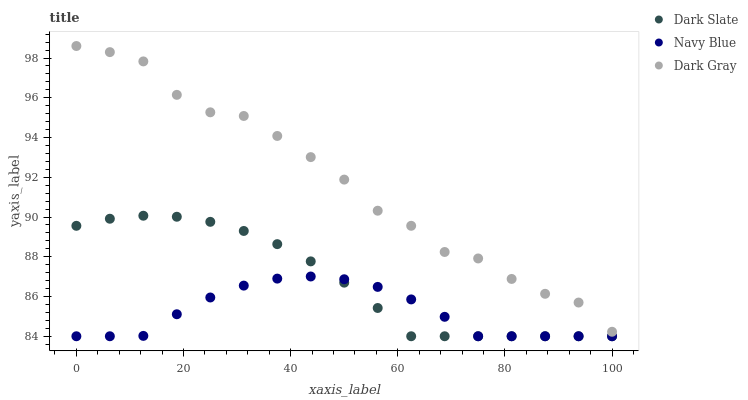Does Navy Blue have the minimum area under the curve?
Answer yes or no. Yes. Does Dark Gray have the maximum area under the curve?
Answer yes or no. Yes. Does Dark Slate have the minimum area under the curve?
Answer yes or no. No. Does Dark Slate have the maximum area under the curve?
Answer yes or no. No. Is Dark Slate the smoothest?
Answer yes or no. Yes. Is Dark Gray the roughest?
Answer yes or no. Yes. Is Navy Blue the smoothest?
Answer yes or no. No. Is Navy Blue the roughest?
Answer yes or no. No. Does Dark Slate have the lowest value?
Answer yes or no. Yes. Does Dark Gray have the highest value?
Answer yes or no. Yes. Does Dark Slate have the highest value?
Answer yes or no. No. Is Navy Blue less than Dark Gray?
Answer yes or no. Yes. Is Dark Gray greater than Dark Slate?
Answer yes or no. Yes. Does Dark Slate intersect Navy Blue?
Answer yes or no. Yes. Is Dark Slate less than Navy Blue?
Answer yes or no. No. Is Dark Slate greater than Navy Blue?
Answer yes or no. No. Does Navy Blue intersect Dark Gray?
Answer yes or no. No. 